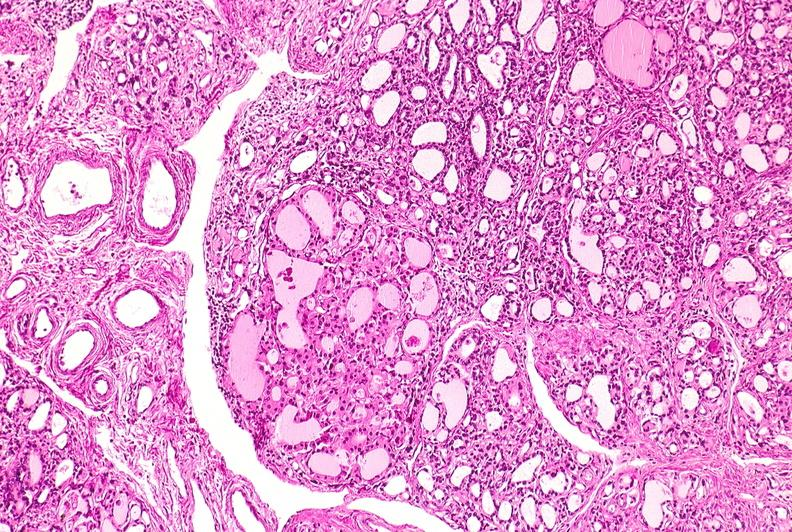where is this part in the figure?
Answer the question using a single word or phrase. Endocrine system 